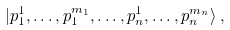Convert formula to latex. <formula><loc_0><loc_0><loc_500><loc_500>| p _ { 1 } ^ { 1 } , \dots , p _ { 1 } ^ { m _ { 1 } } , \dots , p _ { n } ^ { 1 } , \dots , p _ { n } ^ { m _ { n } } \rangle \, ,</formula> 